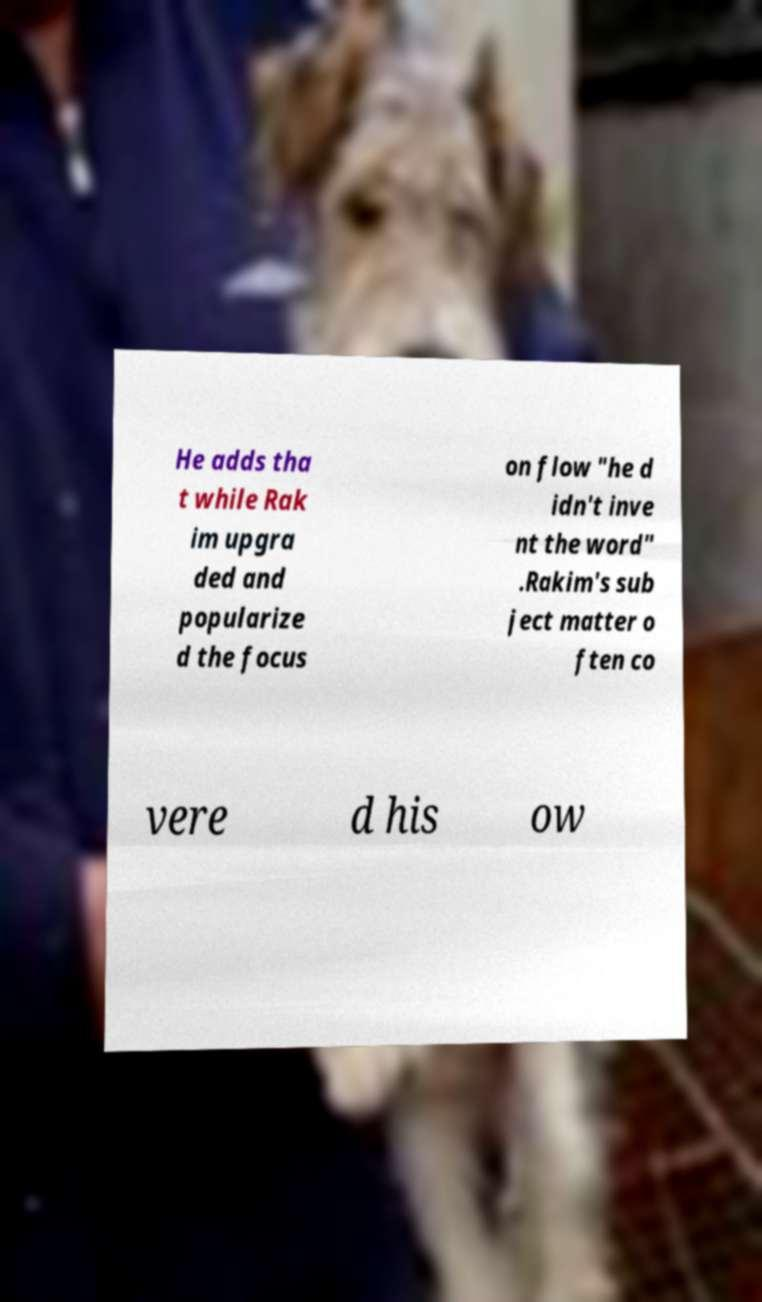Can you accurately transcribe the text from the provided image for me? He adds tha t while Rak im upgra ded and popularize d the focus on flow "he d idn't inve nt the word" .Rakim's sub ject matter o ften co vere d his ow 